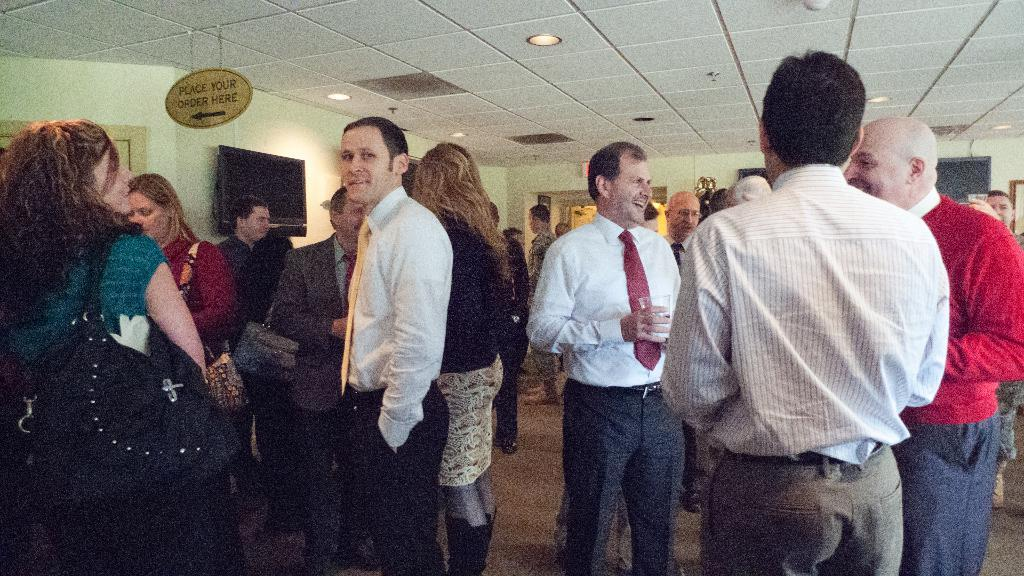What can be seen in the image involving human presence? There are people standing in the image. What is the surface on which the people are standing? The people are standing on a surface. What type of objects are attached to the wall in the image? There are electronic devices on the wall in the image. What can be seen on the roof in the image? There are light arrangements on the roof in the image. What type of jewel is being used as a nail in the image? There is no jewel or nail present in the image. 